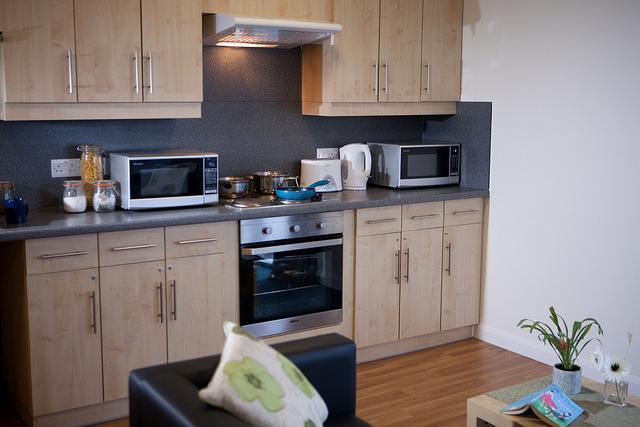How many microwaves are visible?
Give a very brief answer. 2. 